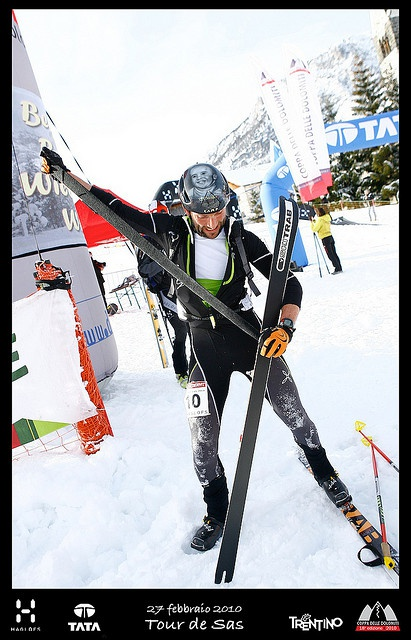Describe the objects in this image and their specific colors. I can see people in black, gray, lightgray, and darkgray tones, skis in black, gray, white, and darkgray tones, skis in black, lightgray, gray, and tan tones, backpack in black, white, and gray tones, and people in black, khaki, and ivory tones in this image. 